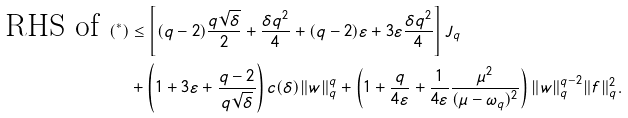Convert formula to latex. <formula><loc_0><loc_0><loc_500><loc_500>\text { RHS of } ( ^ { * } ) & \leq \left [ ( q - 2 ) \frac { q \sqrt { \delta } } { 2 } + \frac { \delta q ^ { 2 } } { 4 } + ( q - 2 ) \varepsilon + 3 \varepsilon \frac { \delta q ^ { 2 } } { 4 } \right ] J _ { q } \\ & + \left ( 1 + 3 \varepsilon + \frac { q - 2 } { q \sqrt { \delta } } \right ) c ( \delta ) \| w \| _ { q } ^ { q } + \left ( 1 + \frac { q } { 4 \varepsilon } + \frac { 1 } { 4 \varepsilon } \frac { \mu ^ { 2 } } { ( \mu - \omega _ { q } ) ^ { 2 } } \right ) \| w \| _ { q } ^ { q - 2 } \| f \| _ { q } ^ { 2 } .</formula> 